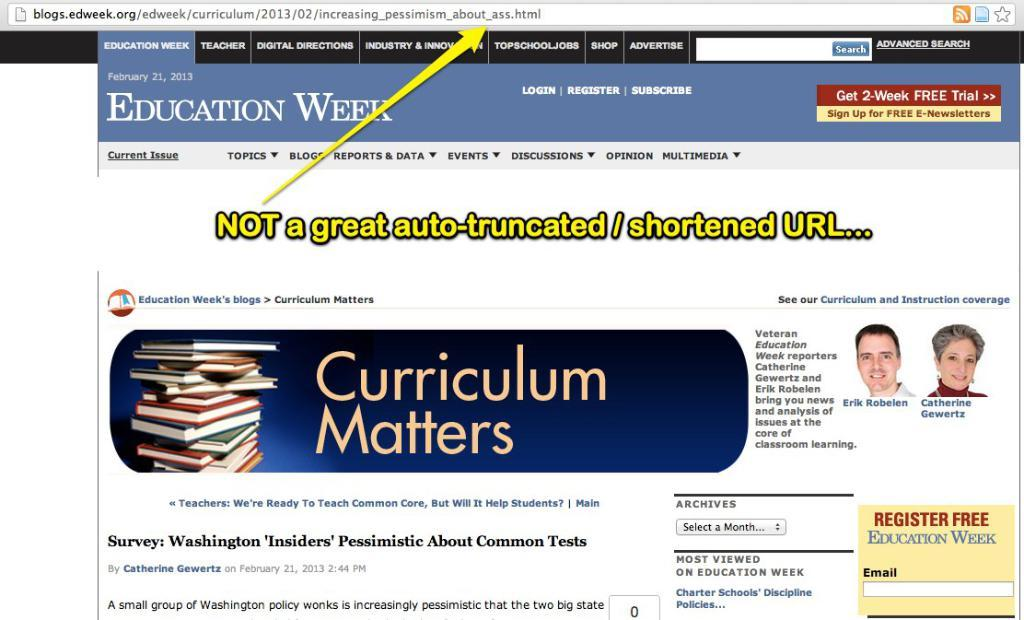<image>
Give a short and clear explanation of the subsequent image. A screenshot of a webpage for Education Week that says Curriculum Matters. 